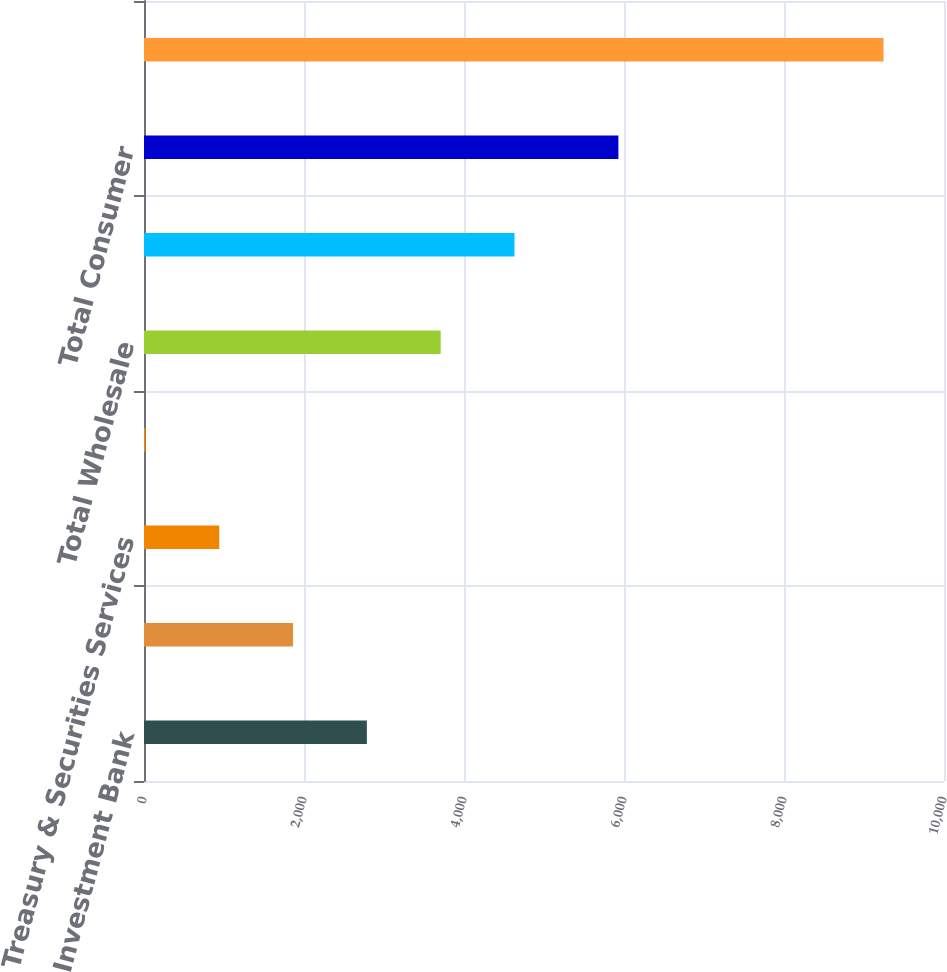<chart> <loc_0><loc_0><loc_500><loc_500><bar_chart><fcel>Investment Bank<fcel>Commercial Banking<fcel>Treasury & Securities Services<fcel>Asset Management<fcel>Total Wholesale<fcel>Retail Financial Services<fcel>Total Consumer<fcel>Total provision for credit<nl><fcel>2785.8<fcel>1863.2<fcel>940.6<fcel>18<fcel>3708.4<fcel>4631<fcel>5930<fcel>9244<nl></chart> 